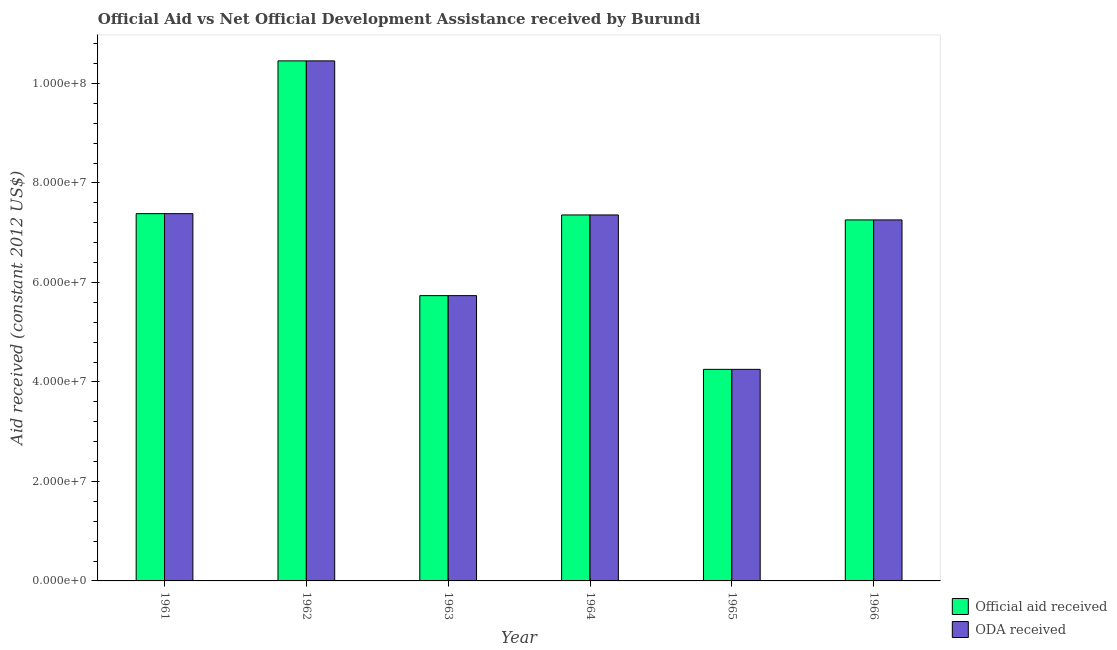How many different coloured bars are there?
Your answer should be compact. 2. Are the number of bars per tick equal to the number of legend labels?
Make the answer very short. Yes. In how many cases, is the number of bars for a given year not equal to the number of legend labels?
Give a very brief answer. 0. What is the official aid received in 1961?
Ensure brevity in your answer.  7.38e+07. Across all years, what is the maximum oda received?
Provide a succinct answer. 1.05e+08. Across all years, what is the minimum official aid received?
Provide a succinct answer. 4.25e+07. In which year was the official aid received maximum?
Your response must be concise. 1962. In which year was the official aid received minimum?
Your response must be concise. 1965. What is the total oda received in the graph?
Provide a short and direct response. 4.24e+08. What is the difference between the official aid received in 1962 and that in 1966?
Your answer should be very brief. 3.20e+07. What is the difference between the official aid received in 1965 and the oda received in 1964?
Provide a short and direct response. -3.10e+07. What is the average oda received per year?
Your response must be concise. 7.07e+07. In the year 1964, what is the difference between the official aid received and oda received?
Give a very brief answer. 0. What is the ratio of the official aid received in 1963 to that in 1965?
Keep it short and to the point. 1.35. Is the difference between the official aid received in 1961 and 1962 greater than the difference between the oda received in 1961 and 1962?
Your answer should be very brief. No. What is the difference between the highest and the second highest official aid received?
Ensure brevity in your answer.  3.07e+07. What is the difference between the highest and the lowest official aid received?
Provide a short and direct response. 6.20e+07. Is the sum of the oda received in 1961 and 1963 greater than the maximum official aid received across all years?
Offer a very short reply. Yes. What does the 1st bar from the left in 1961 represents?
Offer a very short reply. Official aid received. What does the 2nd bar from the right in 1964 represents?
Provide a succinct answer. Official aid received. How many bars are there?
Provide a succinct answer. 12. Does the graph contain any zero values?
Offer a very short reply. No. Does the graph contain grids?
Your response must be concise. No. Where does the legend appear in the graph?
Your answer should be compact. Bottom right. How many legend labels are there?
Your answer should be very brief. 2. How are the legend labels stacked?
Your answer should be compact. Vertical. What is the title of the graph?
Offer a very short reply. Official Aid vs Net Official Development Assistance received by Burundi . Does "Foreign Liabilities" appear as one of the legend labels in the graph?
Provide a succinct answer. No. What is the label or title of the Y-axis?
Offer a very short reply. Aid received (constant 2012 US$). What is the Aid received (constant 2012 US$) in Official aid received in 1961?
Your answer should be very brief. 7.38e+07. What is the Aid received (constant 2012 US$) in ODA received in 1961?
Your answer should be very brief. 7.38e+07. What is the Aid received (constant 2012 US$) of Official aid received in 1962?
Your answer should be compact. 1.05e+08. What is the Aid received (constant 2012 US$) in ODA received in 1962?
Ensure brevity in your answer.  1.05e+08. What is the Aid received (constant 2012 US$) of Official aid received in 1963?
Provide a succinct answer. 5.74e+07. What is the Aid received (constant 2012 US$) of ODA received in 1963?
Offer a terse response. 5.74e+07. What is the Aid received (constant 2012 US$) of Official aid received in 1964?
Give a very brief answer. 7.36e+07. What is the Aid received (constant 2012 US$) of ODA received in 1964?
Provide a succinct answer. 7.36e+07. What is the Aid received (constant 2012 US$) of Official aid received in 1965?
Offer a very short reply. 4.25e+07. What is the Aid received (constant 2012 US$) in ODA received in 1965?
Give a very brief answer. 4.25e+07. What is the Aid received (constant 2012 US$) of Official aid received in 1966?
Ensure brevity in your answer.  7.26e+07. What is the Aid received (constant 2012 US$) of ODA received in 1966?
Your answer should be compact. 7.26e+07. Across all years, what is the maximum Aid received (constant 2012 US$) in Official aid received?
Provide a short and direct response. 1.05e+08. Across all years, what is the maximum Aid received (constant 2012 US$) in ODA received?
Ensure brevity in your answer.  1.05e+08. Across all years, what is the minimum Aid received (constant 2012 US$) of Official aid received?
Provide a succinct answer. 4.25e+07. Across all years, what is the minimum Aid received (constant 2012 US$) of ODA received?
Offer a very short reply. 4.25e+07. What is the total Aid received (constant 2012 US$) in Official aid received in the graph?
Ensure brevity in your answer.  4.24e+08. What is the total Aid received (constant 2012 US$) of ODA received in the graph?
Offer a very short reply. 4.24e+08. What is the difference between the Aid received (constant 2012 US$) of Official aid received in 1961 and that in 1962?
Your response must be concise. -3.07e+07. What is the difference between the Aid received (constant 2012 US$) of ODA received in 1961 and that in 1962?
Your answer should be compact. -3.07e+07. What is the difference between the Aid received (constant 2012 US$) in Official aid received in 1961 and that in 1963?
Provide a short and direct response. 1.65e+07. What is the difference between the Aid received (constant 2012 US$) in ODA received in 1961 and that in 1963?
Keep it short and to the point. 1.65e+07. What is the difference between the Aid received (constant 2012 US$) in ODA received in 1961 and that in 1964?
Give a very brief answer. 2.60e+05. What is the difference between the Aid received (constant 2012 US$) of Official aid received in 1961 and that in 1965?
Ensure brevity in your answer.  3.13e+07. What is the difference between the Aid received (constant 2012 US$) in ODA received in 1961 and that in 1965?
Offer a terse response. 3.13e+07. What is the difference between the Aid received (constant 2012 US$) in Official aid received in 1961 and that in 1966?
Offer a very short reply. 1.26e+06. What is the difference between the Aid received (constant 2012 US$) in ODA received in 1961 and that in 1966?
Your answer should be compact. 1.26e+06. What is the difference between the Aid received (constant 2012 US$) of Official aid received in 1962 and that in 1963?
Your answer should be compact. 4.72e+07. What is the difference between the Aid received (constant 2012 US$) of ODA received in 1962 and that in 1963?
Make the answer very short. 4.72e+07. What is the difference between the Aid received (constant 2012 US$) of Official aid received in 1962 and that in 1964?
Ensure brevity in your answer.  3.10e+07. What is the difference between the Aid received (constant 2012 US$) of ODA received in 1962 and that in 1964?
Provide a short and direct response. 3.10e+07. What is the difference between the Aid received (constant 2012 US$) in Official aid received in 1962 and that in 1965?
Your response must be concise. 6.20e+07. What is the difference between the Aid received (constant 2012 US$) in ODA received in 1962 and that in 1965?
Offer a very short reply. 6.20e+07. What is the difference between the Aid received (constant 2012 US$) of Official aid received in 1962 and that in 1966?
Offer a very short reply. 3.20e+07. What is the difference between the Aid received (constant 2012 US$) in ODA received in 1962 and that in 1966?
Give a very brief answer. 3.20e+07. What is the difference between the Aid received (constant 2012 US$) in Official aid received in 1963 and that in 1964?
Ensure brevity in your answer.  -1.62e+07. What is the difference between the Aid received (constant 2012 US$) in ODA received in 1963 and that in 1964?
Keep it short and to the point. -1.62e+07. What is the difference between the Aid received (constant 2012 US$) of Official aid received in 1963 and that in 1965?
Provide a short and direct response. 1.48e+07. What is the difference between the Aid received (constant 2012 US$) in ODA received in 1963 and that in 1965?
Your response must be concise. 1.48e+07. What is the difference between the Aid received (constant 2012 US$) in Official aid received in 1963 and that in 1966?
Provide a short and direct response. -1.52e+07. What is the difference between the Aid received (constant 2012 US$) in ODA received in 1963 and that in 1966?
Offer a very short reply. -1.52e+07. What is the difference between the Aid received (constant 2012 US$) of Official aid received in 1964 and that in 1965?
Provide a succinct answer. 3.10e+07. What is the difference between the Aid received (constant 2012 US$) in ODA received in 1964 and that in 1965?
Make the answer very short. 3.10e+07. What is the difference between the Aid received (constant 2012 US$) in Official aid received in 1965 and that in 1966?
Ensure brevity in your answer.  -3.00e+07. What is the difference between the Aid received (constant 2012 US$) in ODA received in 1965 and that in 1966?
Your answer should be very brief. -3.00e+07. What is the difference between the Aid received (constant 2012 US$) in Official aid received in 1961 and the Aid received (constant 2012 US$) in ODA received in 1962?
Ensure brevity in your answer.  -3.07e+07. What is the difference between the Aid received (constant 2012 US$) in Official aid received in 1961 and the Aid received (constant 2012 US$) in ODA received in 1963?
Provide a short and direct response. 1.65e+07. What is the difference between the Aid received (constant 2012 US$) of Official aid received in 1961 and the Aid received (constant 2012 US$) of ODA received in 1965?
Provide a succinct answer. 3.13e+07. What is the difference between the Aid received (constant 2012 US$) of Official aid received in 1961 and the Aid received (constant 2012 US$) of ODA received in 1966?
Keep it short and to the point. 1.26e+06. What is the difference between the Aid received (constant 2012 US$) in Official aid received in 1962 and the Aid received (constant 2012 US$) in ODA received in 1963?
Give a very brief answer. 4.72e+07. What is the difference between the Aid received (constant 2012 US$) of Official aid received in 1962 and the Aid received (constant 2012 US$) of ODA received in 1964?
Your response must be concise. 3.10e+07. What is the difference between the Aid received (constant 2012 US$) of Official aid received in 1962 and the Aid received (constant 2012 US$) of ODA received in 1965?
Offer a very short reply. 6.20e+07. What is the difference between the Aid received (constant 2012 US$) of Official aid received in 1962 and the Aid received (constant 2012 US$) of ODA received in 1966?
Offer a terse response. 3.20e+07. What is the difference between the Aid received (constant 2012 US$) in Official aid received in 1963 and the Aid received (constant 2012 US$) in ODA received in 1964?
Offer a terse response. -1.62e+07. What is the difference between the Aid received (constant 2012 US$) of Official aid received in 1963 and the Aid received (constant 2012 US$) of ODA received in 1965?
Provide a short and direct response. 1.48e+07. What is the difference between the Aid received (constant 2012 US$) of Official aid received in 1963 and the Aid received (constant 2012 US$) of ODA received in 1966?
Provide a succinct answer. -1.52e+07. What is the difference between the Aid received (constant 2012 US$) of Official aid received in 1964 and the Aid received (constant 2012 US$) of ODA received in 1965?
Provide a succinct answer. 3.10e+07. What is the difference between the Aid received (constant 2012 US$) of Official aid received in 1965 and the Aid received (constant 2012 US$) of ODA received in 1966?
Your answer should be compact. -3.00e+07. What is the average Aid received (constant 2012 US$) in Official aid received per year?
Give a very brief answer. 7.07e+07. What is the average Aid received (constant 2012 US$) in ODA received per year?
Provide a succinct answer. 7.07e+07. In the year 1965, what is the difference between the Aid received (constant 2012 US$) of Official aid received and Aid received (constant 2012 US$) of ODA received?
Provide a short and direct response. 0. What is the ratio of the Aid received (constant 2012 US$) in Official aid received in 1961 to that in 1962?
Your response must be concise. 0.71. What is the ratio of the Aid received (constant 2012 US$) in ODA received in 1961 to that in 1962?
Give a very brief answer. 0.71. What is the ratio of the Aid received (constant 2012 US$) of Official aid received in 1961 to that in 1963?
Offer a terse response. 1.29. What is the ratio of the Aid received (constant 2012 US$) of ODA received in 1961 to that in 1963?
Offer a terse response. 1.29. What is the ratio of the Aid received (constant 2012 US$) of Official aid received in 1961 to that in 1965?
Provide a short and direct response. 1.74. What is the ratio of the Aid received (constant 2012 US$) of ODA received in 1961 to that in 1965?
Your answer should be very brief. 1.74. What is the ratio of the Aid received (constant 2012 US$) of Official aid received in 1961 to that in 1966?
Your response must be concise. 1.02. What is the ratio of the Aid received (constant 2012 US$) of ODA received in 1961 to that in 1966?
Provide a succinct answer. 1.02. What is the ratio of the Aid received (constant 2012 US$) in Official aid received in 1962 to that in 1963?
Provide a succinct answer. 1.82. What is the ratio of the Aid received (constant 2012 US$) in ODA received in 1962 to that in 1963?
Provide a short and direct response. 1.82. What is the ratio of the Aid received (constant 2012 US$) in Official aid received in 1962 to that in 1964?
Offer a terse response. 1.42. What is the ratio of the Aid received (constant 2012 US$) of ODA received in 1962 to that in 1964?
Provide a short and direct response. 1.42. What is the ratio of the Aid received (constant 2012 US$) in Official aid received in 1962 to that in 1965?
Your response must be concise. 2.46. What is the ratio of the Aid received (constant 2012 US$) of ODA received in 1962 to that in 1965?
Ensure brevity in your answer.  2.46. What is the ratio of the Aid received (constant 2012 US$) of Official aid received in 1962 to that in 1966?
Give a very brief answer. 1.44. What is the ratio of the Aid received (constant 2012 US$) in ODA received in 1962 to that in 1966?
Offer a very short reply. 1.44. What is the ratio of the Aid received (constant 2012 US$) in Official aid received in 1963 to that in 1964?
Your response must be concise. 0.78. What is the ratio of the Aid received (constant 2012 US$) of ODA received in 1963 to that in 1964?
Your response must be concise. 0.78. What is the ratio of the Aid received (constant 2012 US$) of Official aid received in 1963 to that in 1965?
Your answer should be very brief. 1.35. What is the ratio of the Aid received (constant 2012 US$) in ODA received in 1963 to that in 1965?
Your response must be concise. 1.35. What is the ratio of the Aid received (constant 2012 US$) in Official aid received in 1963 to that in 1966?
Offer a terse response. 0.79. What is the ratio of the Aid received (constant 2012 US$) of ODA received in 1963 to that in 1966?
Provide a succinct answer. 0.79. What is the ratio of the Aid received (constant 2012 US$) of Official aid received in 1964 to that in 1965?
Give a very brief answer. 1.73. What is the ratio of the Aid received (constant 2012 US$) of ODA received in 1964 to that in 1965?
Offer a very short reply. 1.73. What is the ratio of the Aid received (constant 2012 US$) in Official aid received in 1964 to that in 1966?
Give a very brief answer. 1.01. What is the ratio of the Aid received (constant 2012 US$) of ODA received in 1964 to that in 1966?
Keep it short and to the point. 1.01. What is the ratio of the Aid received (constant 2012 US$) in Official aid received in 1965 to that in 1966?
Keep it short and to the point. 0.59. What is the ratio of the Aid received (constant 2012 US$) in ODA received in 1965 to that in 1966?
Your answer should be compact. 0.59. What is the difference between the highest and the second highest Aid received (constant 2012 US$) in Official aid received?
Give a very brief answer. 3.07e+07. What is the difference between the highest and the second highest Aid received (constant 2012 US$) in ODA received?
Your response must be concise. 3.07e+07. What is the difference between the highest and the lowest Aid received (constant 2012 US$) in Official aid received?
Your response must be concise. 6.20e+07. What is the difference between the highest and the lowest Aid received (constant 2012 US$) of ODA received?
Provide a short and direct response. 6.20e+07. 